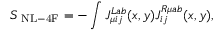<formula> <loc_0><loc_0><loc_500><loc_500>S _ { N L - 4 F } = - \int J _ { \mu i j } ^ { L a b } ( x , y ) J _ { i j } ^ { R \mu a b } ( x , y ) ,</formula> 